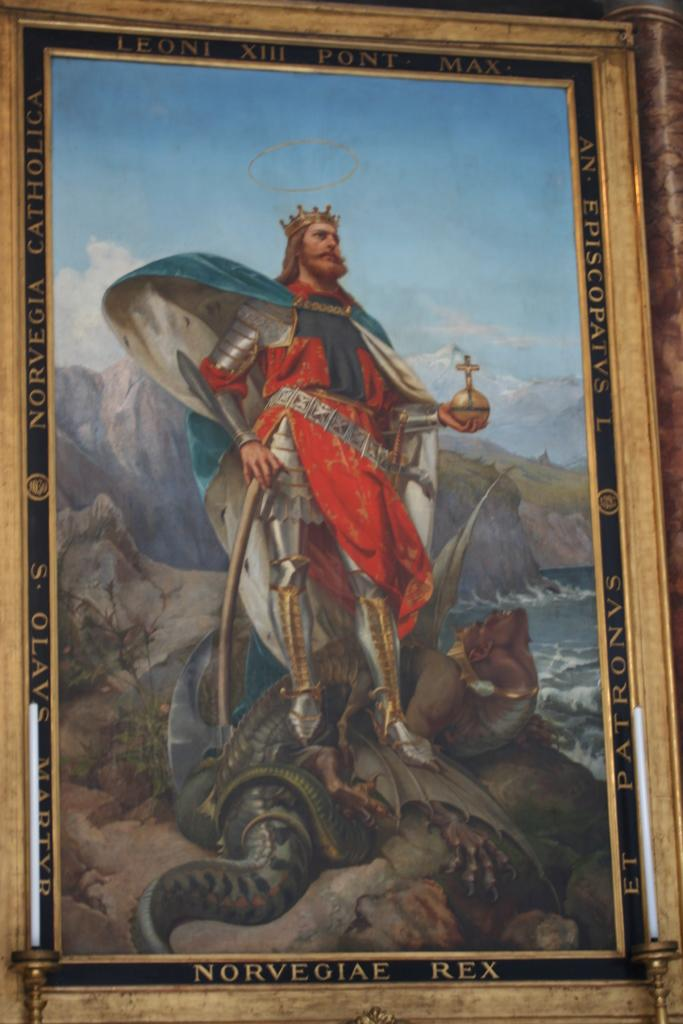<image>
Give a short and clear explanation of the subsequent image. A painting of a king that says Norvegiae Rex at the bottom. 